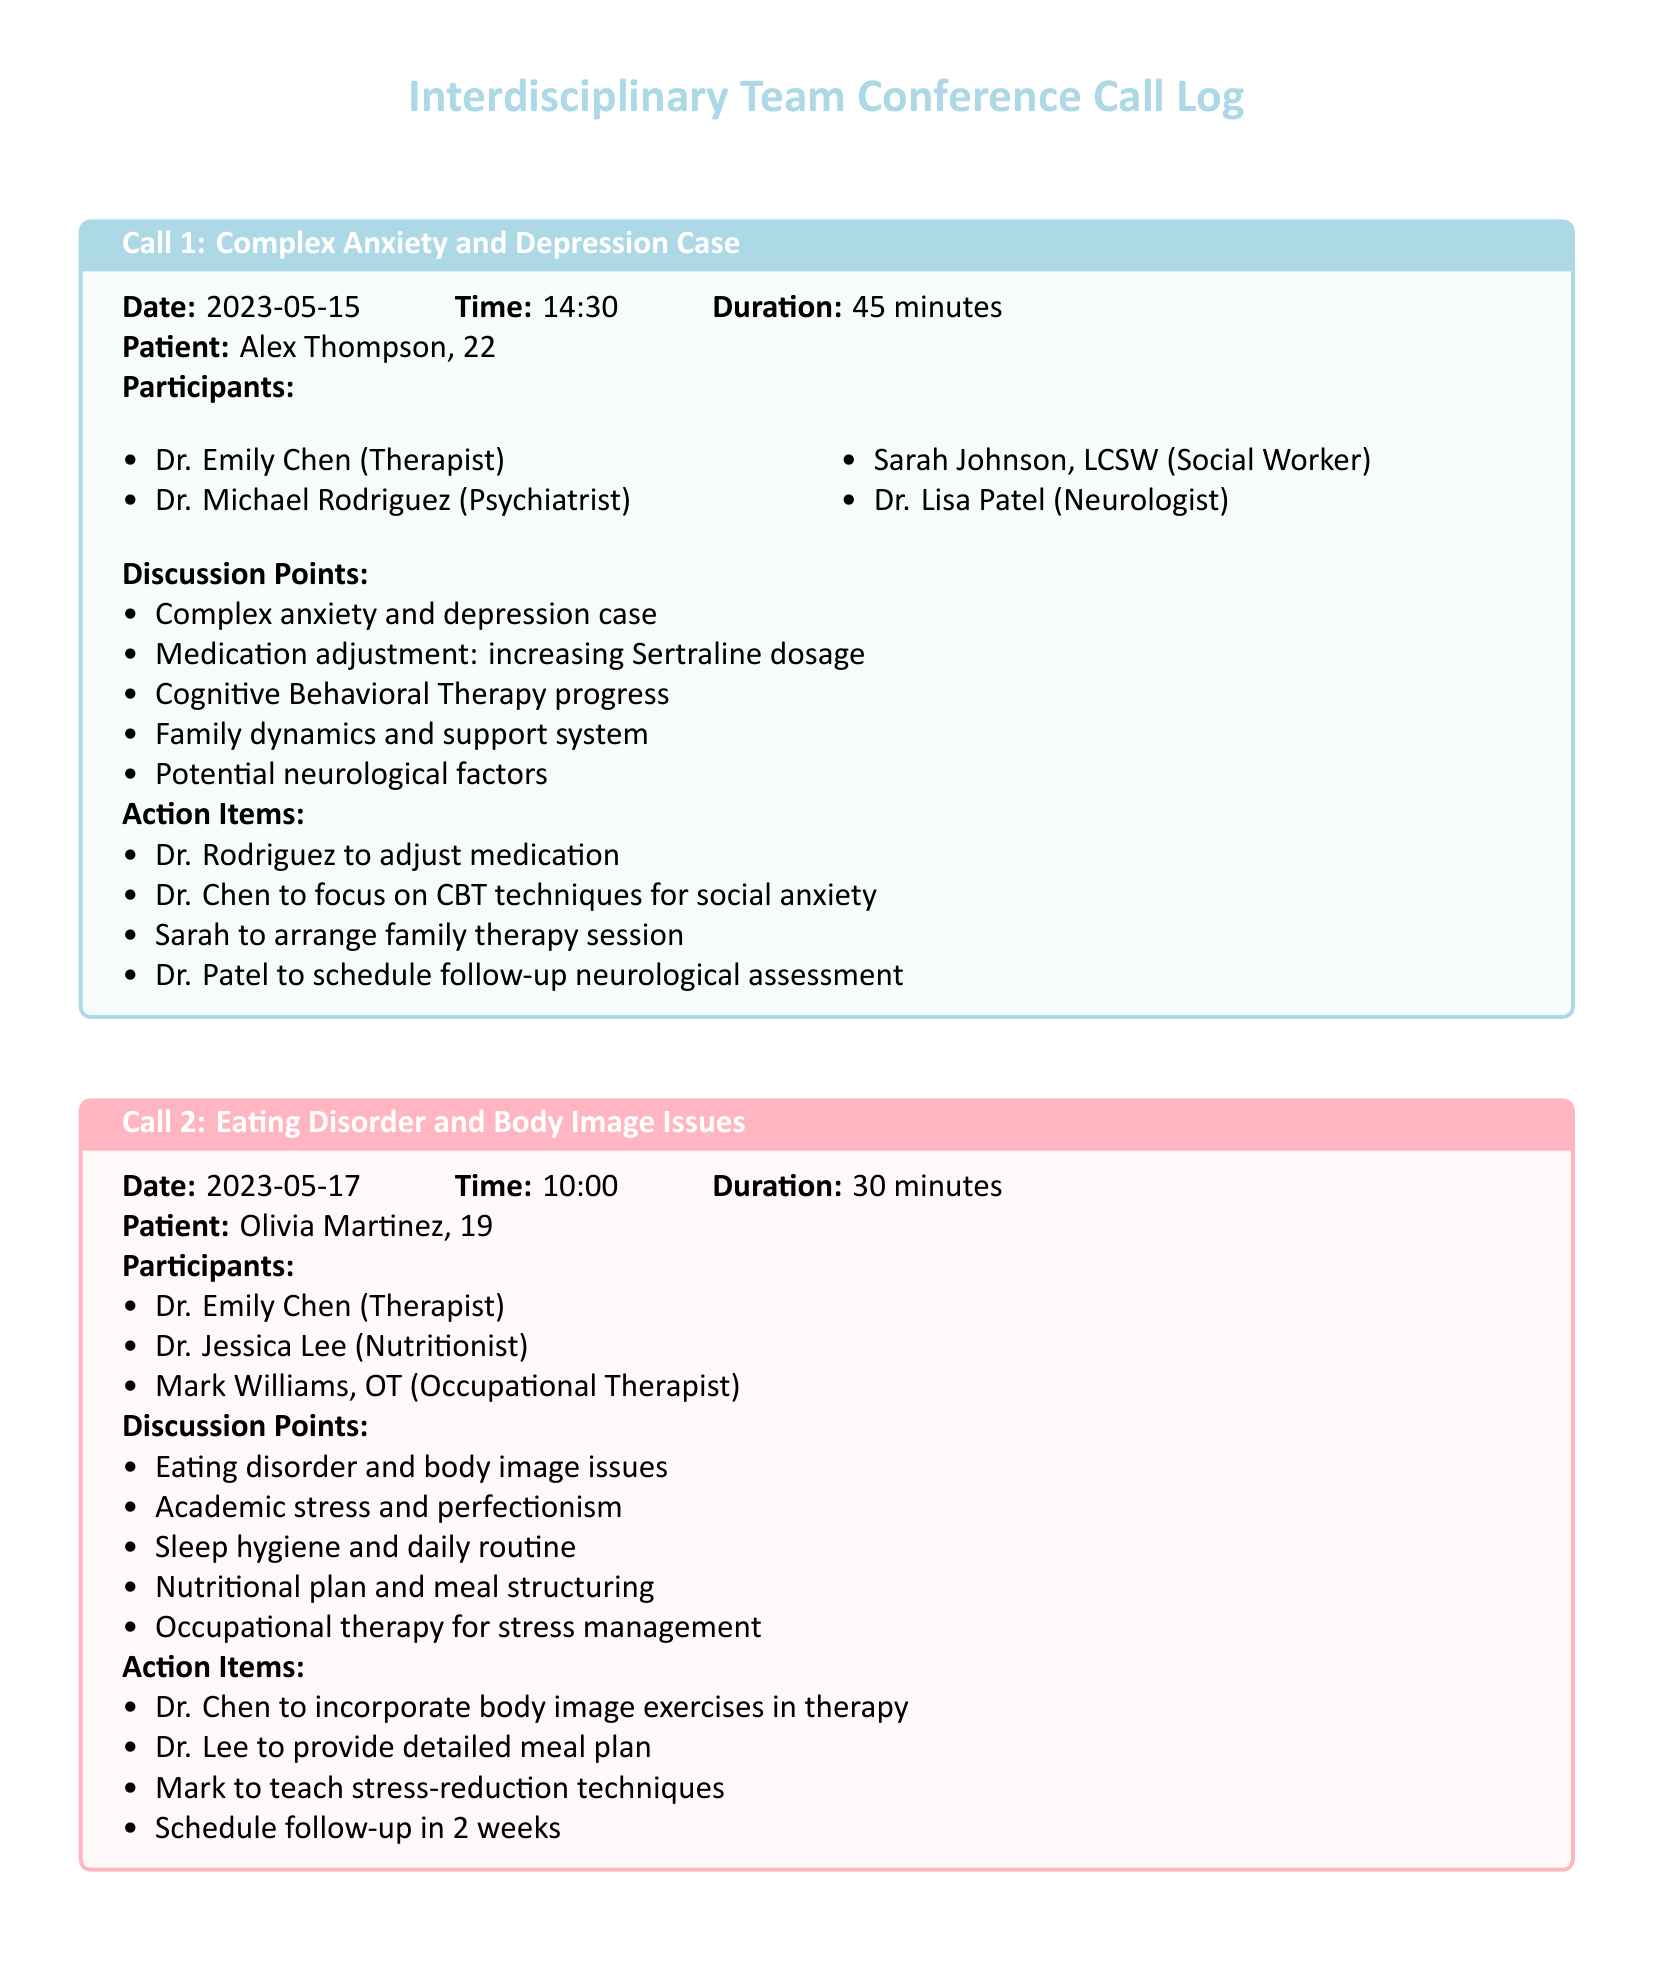What is the date of Call 1? The date for Call 1 is specified in the document under its section headings.
Answer: 2023-05-15 Who is the psychiatrist participating in Call 1? The participants in Call 1 list all team members, including the psychiatrist.
Answer: Dr. Michael Rodriguez What is the main topic discussed in Call 2? The discussion points in Call 2 outline the issues addressed during the call, revealing its main topic.
Answer: Eating disorder and body image issues How long did Call 2 last? The duration of each call is mentioned at the beginning of their respective sections.
Answer: 30 minutes What action item is assigned to Dr. Chen in Call 2? The action items list the responsibilities each participant agreed upon during the call.
Answer: Incorporate body image exercises in therapy What is the patient's age in Call 1? The age of the patient is included in the patient details at the beginning of Call 1.
Answer: 22 What type of therapy is Dr. Chen focusing on in Call 1? The discussion points in Call 1 specify the type of therapy relevant to the patient.
Answer: Cognitive Behavioral Therapy What is one of the discussion points regarding Olivia Martinez? The discussion points in Call 2 list multiple aspects of the patient's situation.
Answer: Academic stress and perfectionism What is the follow-up frequency mentioned in Call 2? The action items include a scheduling detail for follow-up sessions after the call.
Answer: 2 weeks 